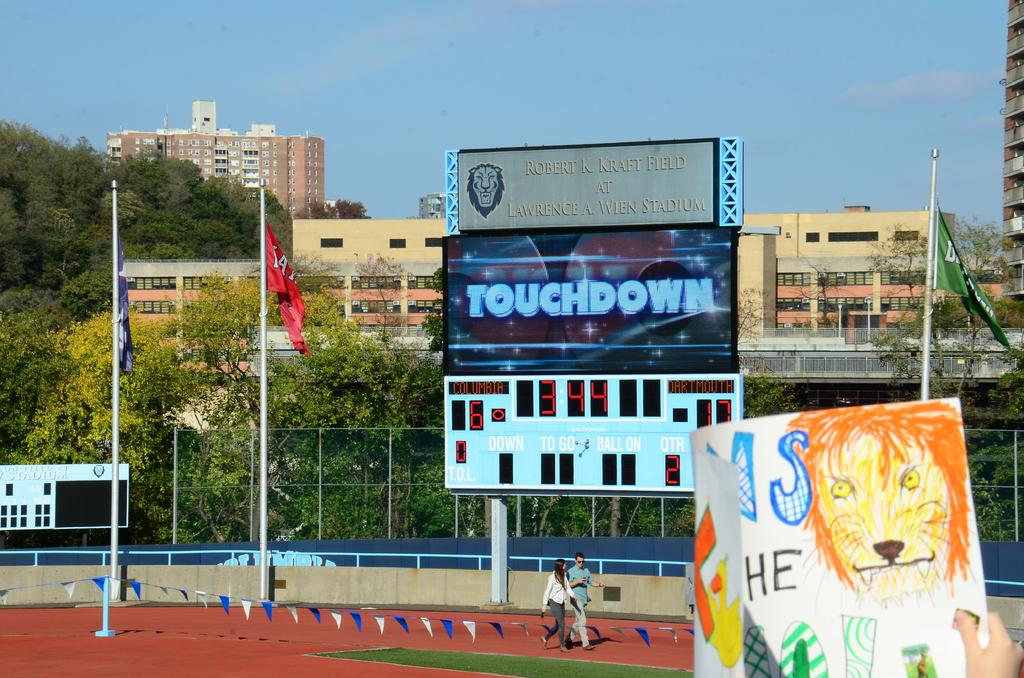<image>
Share a concise interpretation of the image provided. a sign on a scoreboard that says touchdown on it 